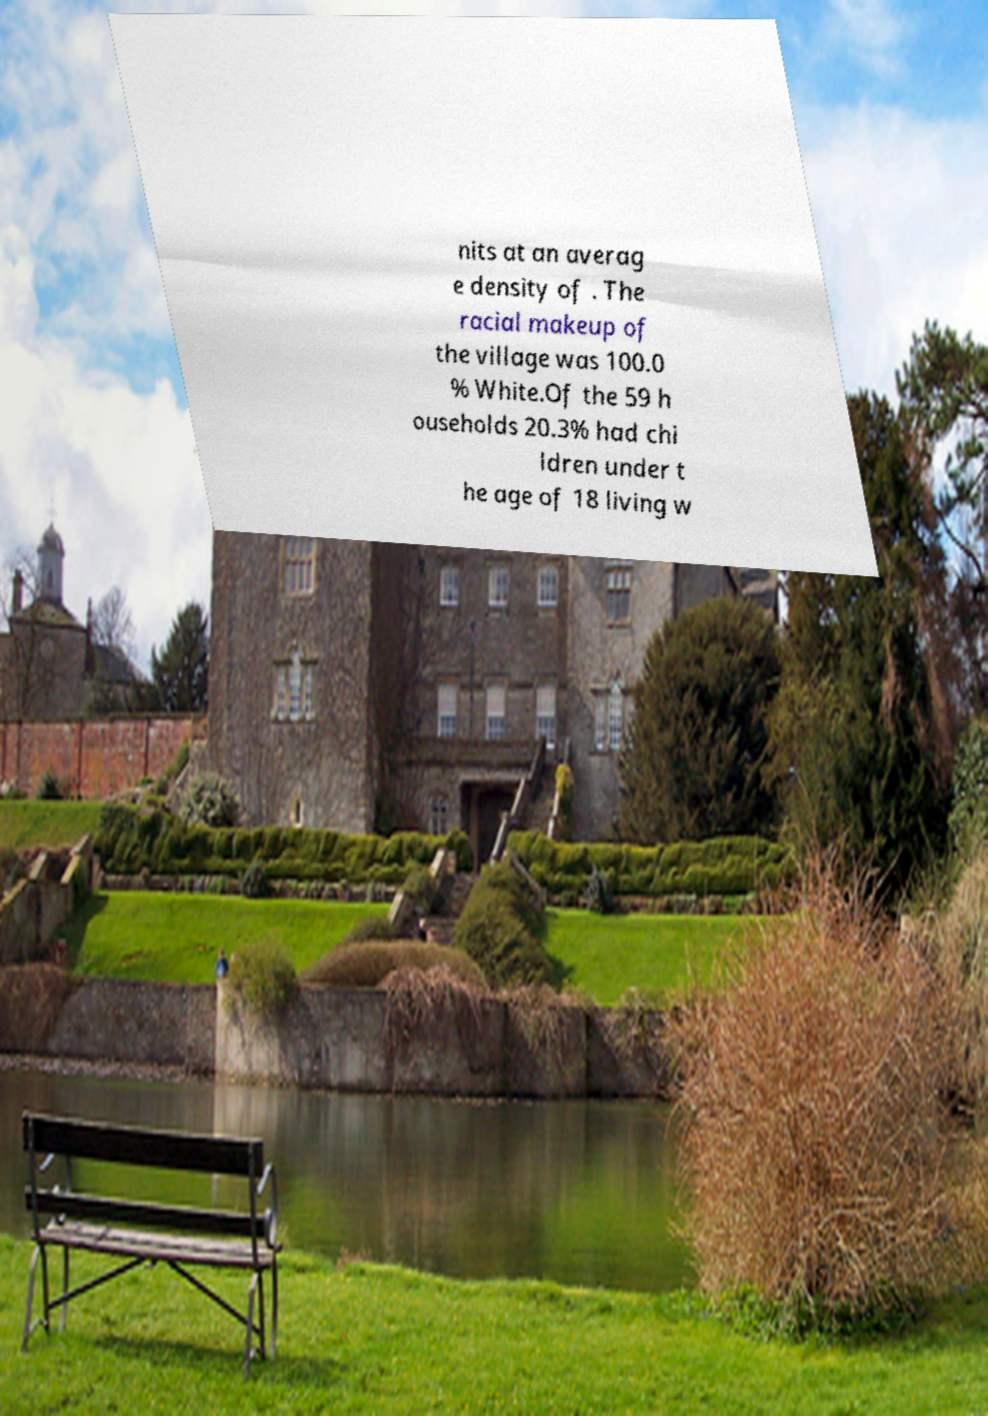Please identify and transcribe the text found in this image. nits at an averag e density of . The racial makeup of the village was 100.0 % White.Of the 59 h ouseholds 20.3% had chi ldren under t he age of 18 living w 